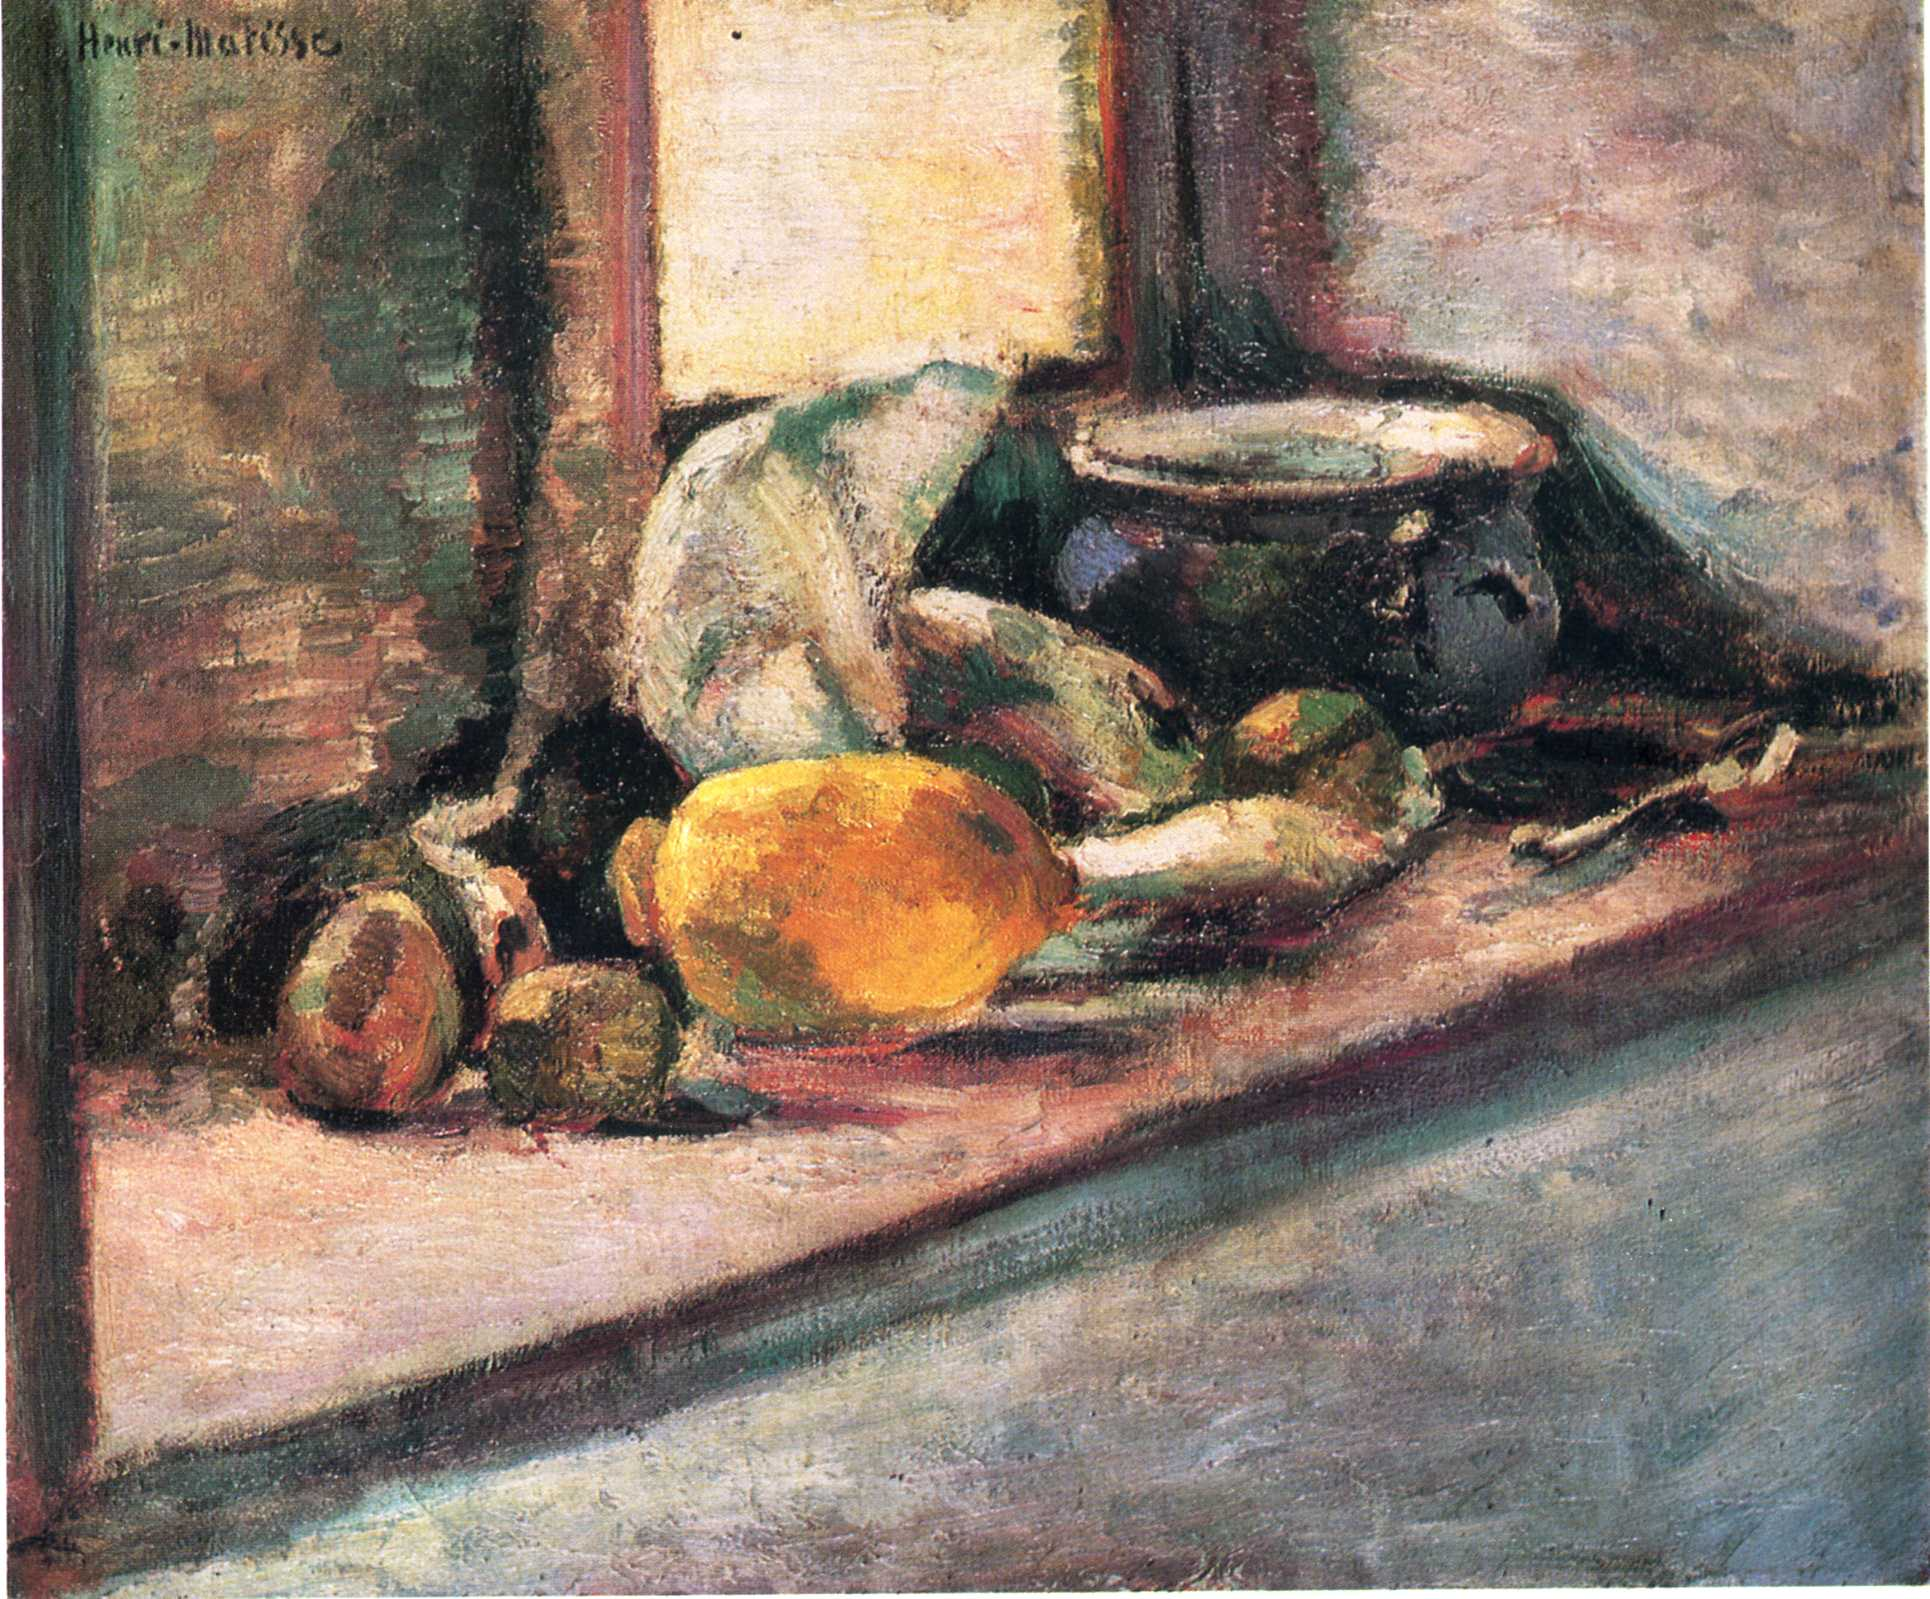Can you describe the main features of this image for me? This image features a vibrant still life painting by Henri Matisse, characterized by his signature expressive use of color and dynamic brushwork. The scene captures an array of objects artfully arranged on a table, including a green vase, a bowl, and various pieces of fruit like apples and oranges, which are rendered in rich, luminous colors. Matisse's approach here leans towards Post-Impressionism, with a hint of Fauvism, evident in the bold, unconventional color palette and the loose, gestural brushstrokes. The background features muted tones that enhance the warm colors of the still life setup, creating a striking contrast. This painting is a prime example of Matisse's skill in blending form and color to capture the simple beauty of everyday objects. 